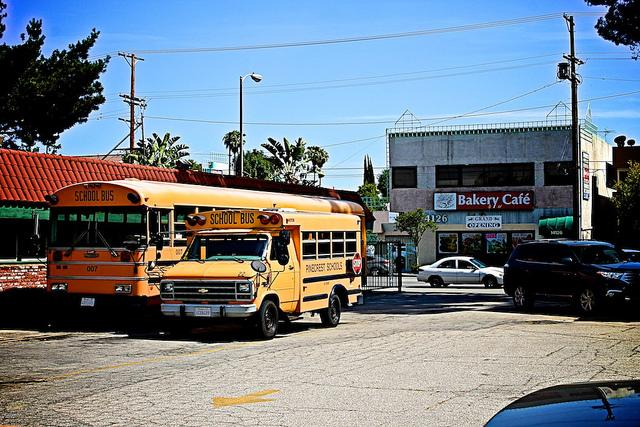When stopped what part of the smaller bus might most frequently pop out away from it's side? stop sign 